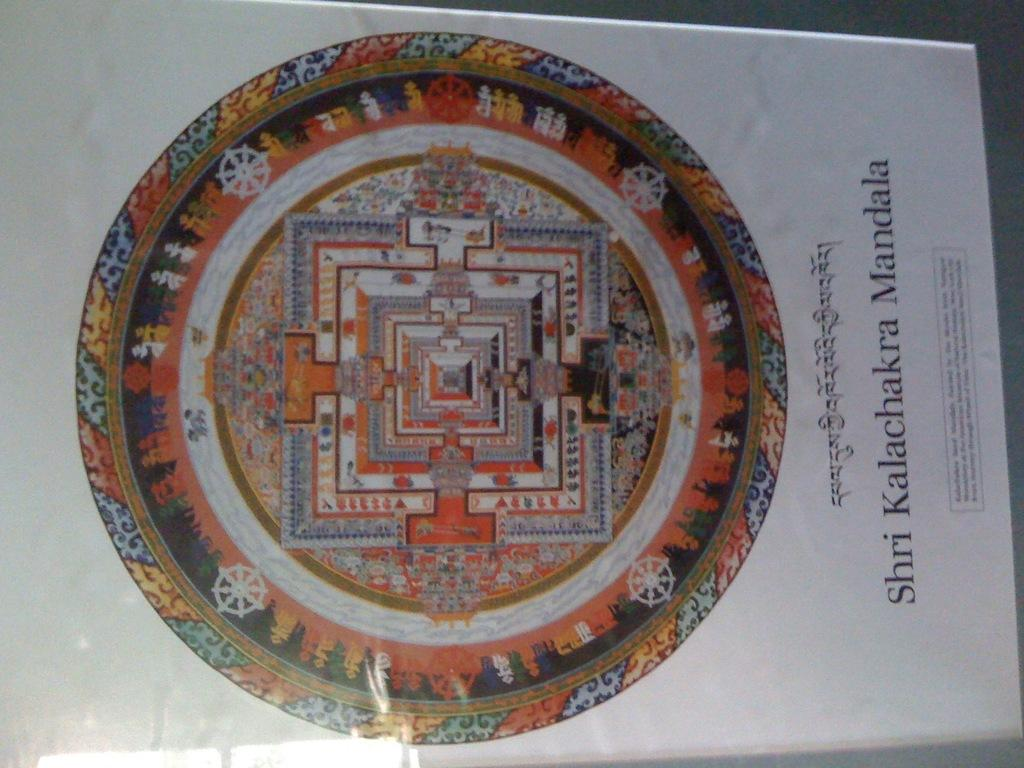<image>
Offer a succinct explanation of the picture presented. A color illustration of the Shri Kalachakra Mandala. 